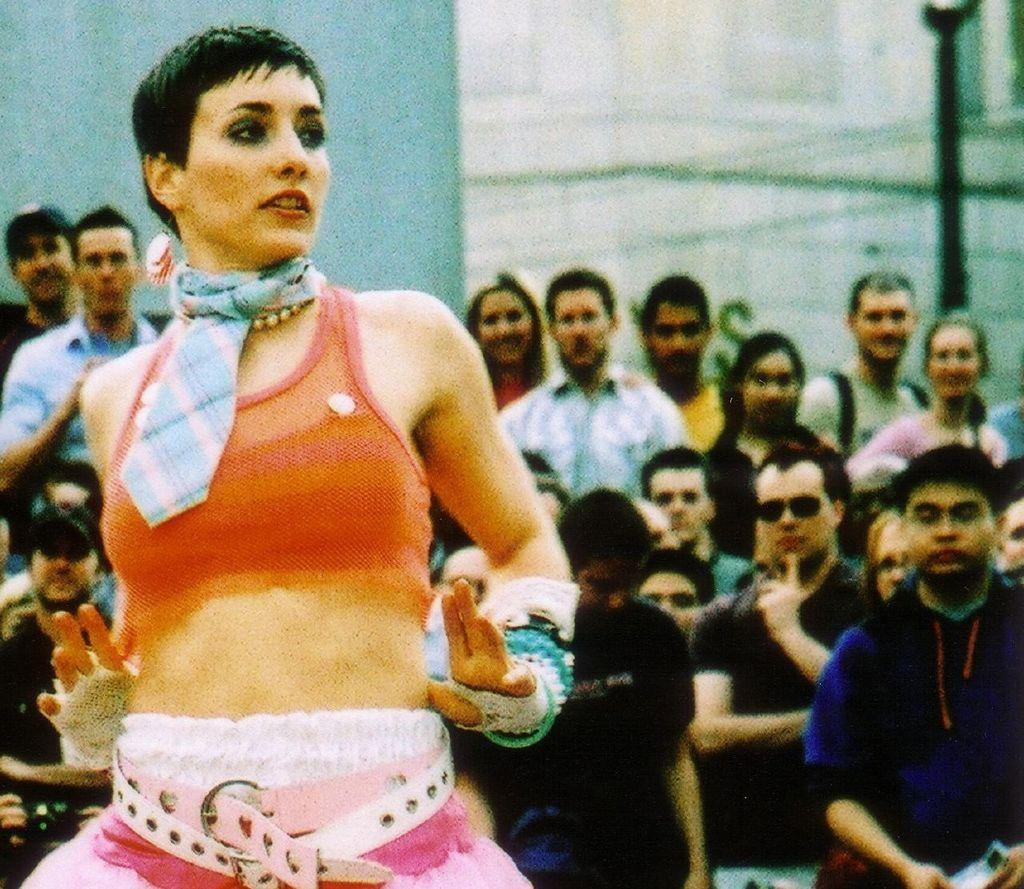Who is the main subject in the foreground of the image? There is a woman in the foreground of the image. What can be seen behind the woman? There is a crowd behind the woman. What type of cub is visible in the image? There is no cub present in the image. 